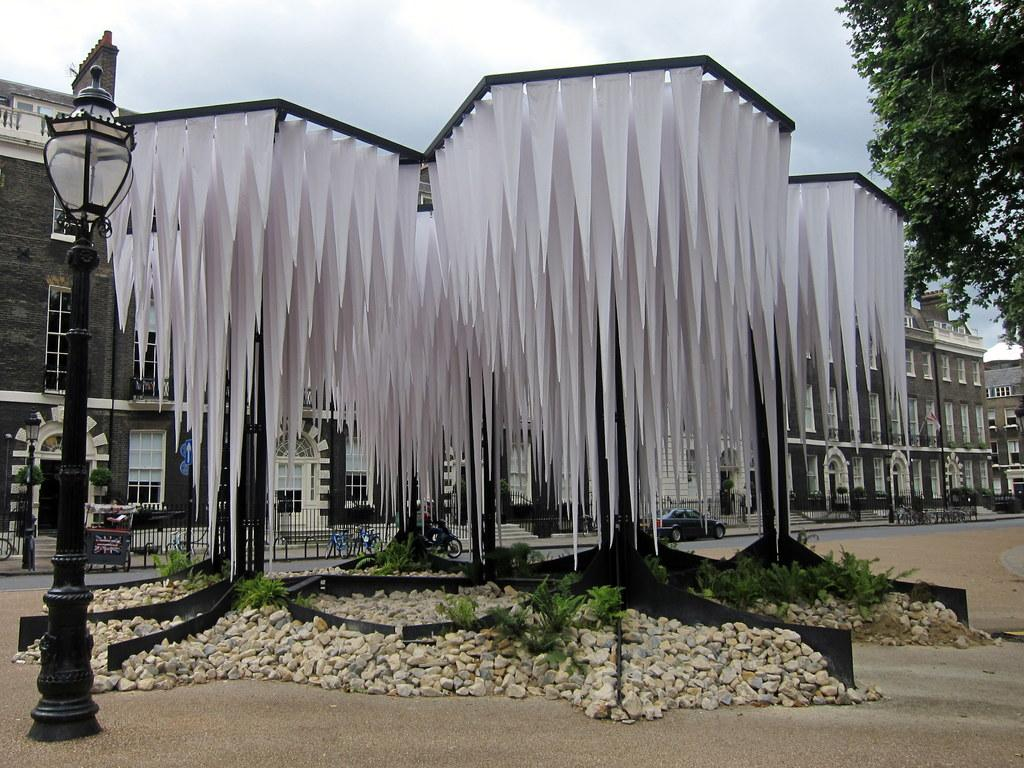What type of structures can be seen in the image? There are buildings in the image. What architectural features can be observed on the buildings? There are windows visible on the buildings. What type of vegetation is present in the image? There are plants and trees in the image. What is the purpose of the light pole in the image? The light pole provides illumination in the image. What object is used to display items in the image? There is a stand in the image. What type of clothing can be seen in the image? There are clothes in the image. What type of natural elements are present in the image? There are rocks in the image. What part of the natural environment is visible in the image? The sky is visible in the image. What type of transportation is present in the image? There are vehicles on the road in the image. What type of religion is practiced by the person in the image? There is no person present in the image, so it is not possible to determine their religious beliefs. What is the condition of the chin of the person in the image? There is no person present in the image, so it is not possible to determine the condition of their chin. 